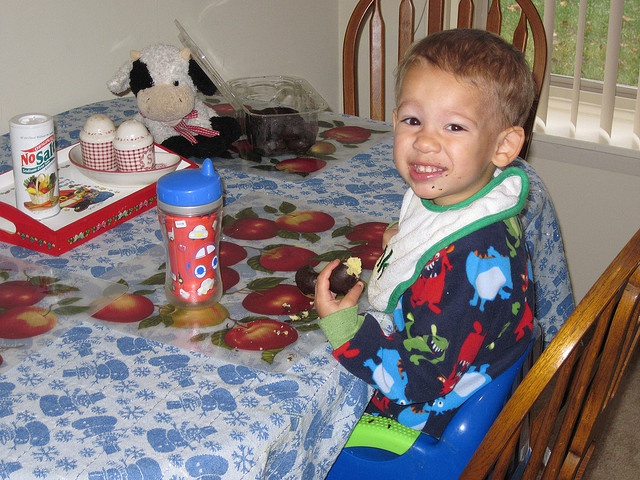Describe the objects in this image and their specific colors. I can see dining table in darkgray, gray, and lightgray tones, people in darkgray, black, tan, and lightgray tones, chair in darkgray, maroon, brown, and black tones, chair in darkgray, maroon, and gray tones, and cup in darkgray, salmon, blue, gray, and brown tones in this image. 